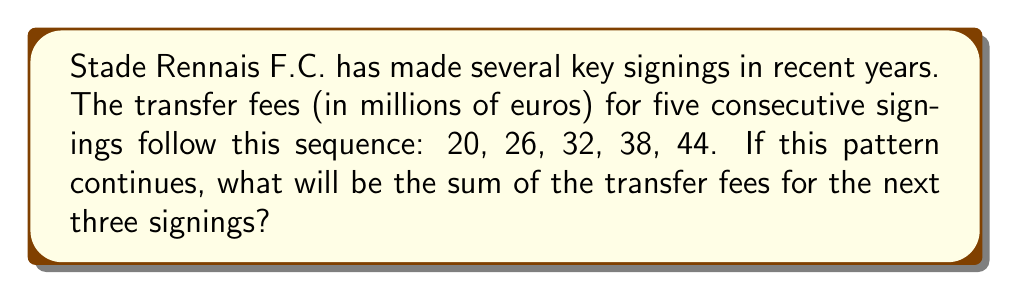Solve this math problem. Let's approach this step-by-step:

1) First, we need to identify the pattern in the given sequence:
   20, 26, 32, 38, 44

2) We can see that each term increases by 6 million euros:
   26 - 20 = 6
   32 - 26 = 6
   38 - 32 = 6
   44 - 38 = 6

3) So, the sequence is an arithmetic progression with a common difference of 6.

4) We need to find the next three terms in this sequence:
   6th term: 44 + 6 = 50
   7th term: 50 + 6 = 56
   8th term: 56 + 6 = 62

5) Now, we need to sum these three terms:
   $$ 50 + 56 + 62 = 168 $$

Therefore, the sum of the transfer fees for the next three signings would be 168 million euros.
Answer: 168 million euros 